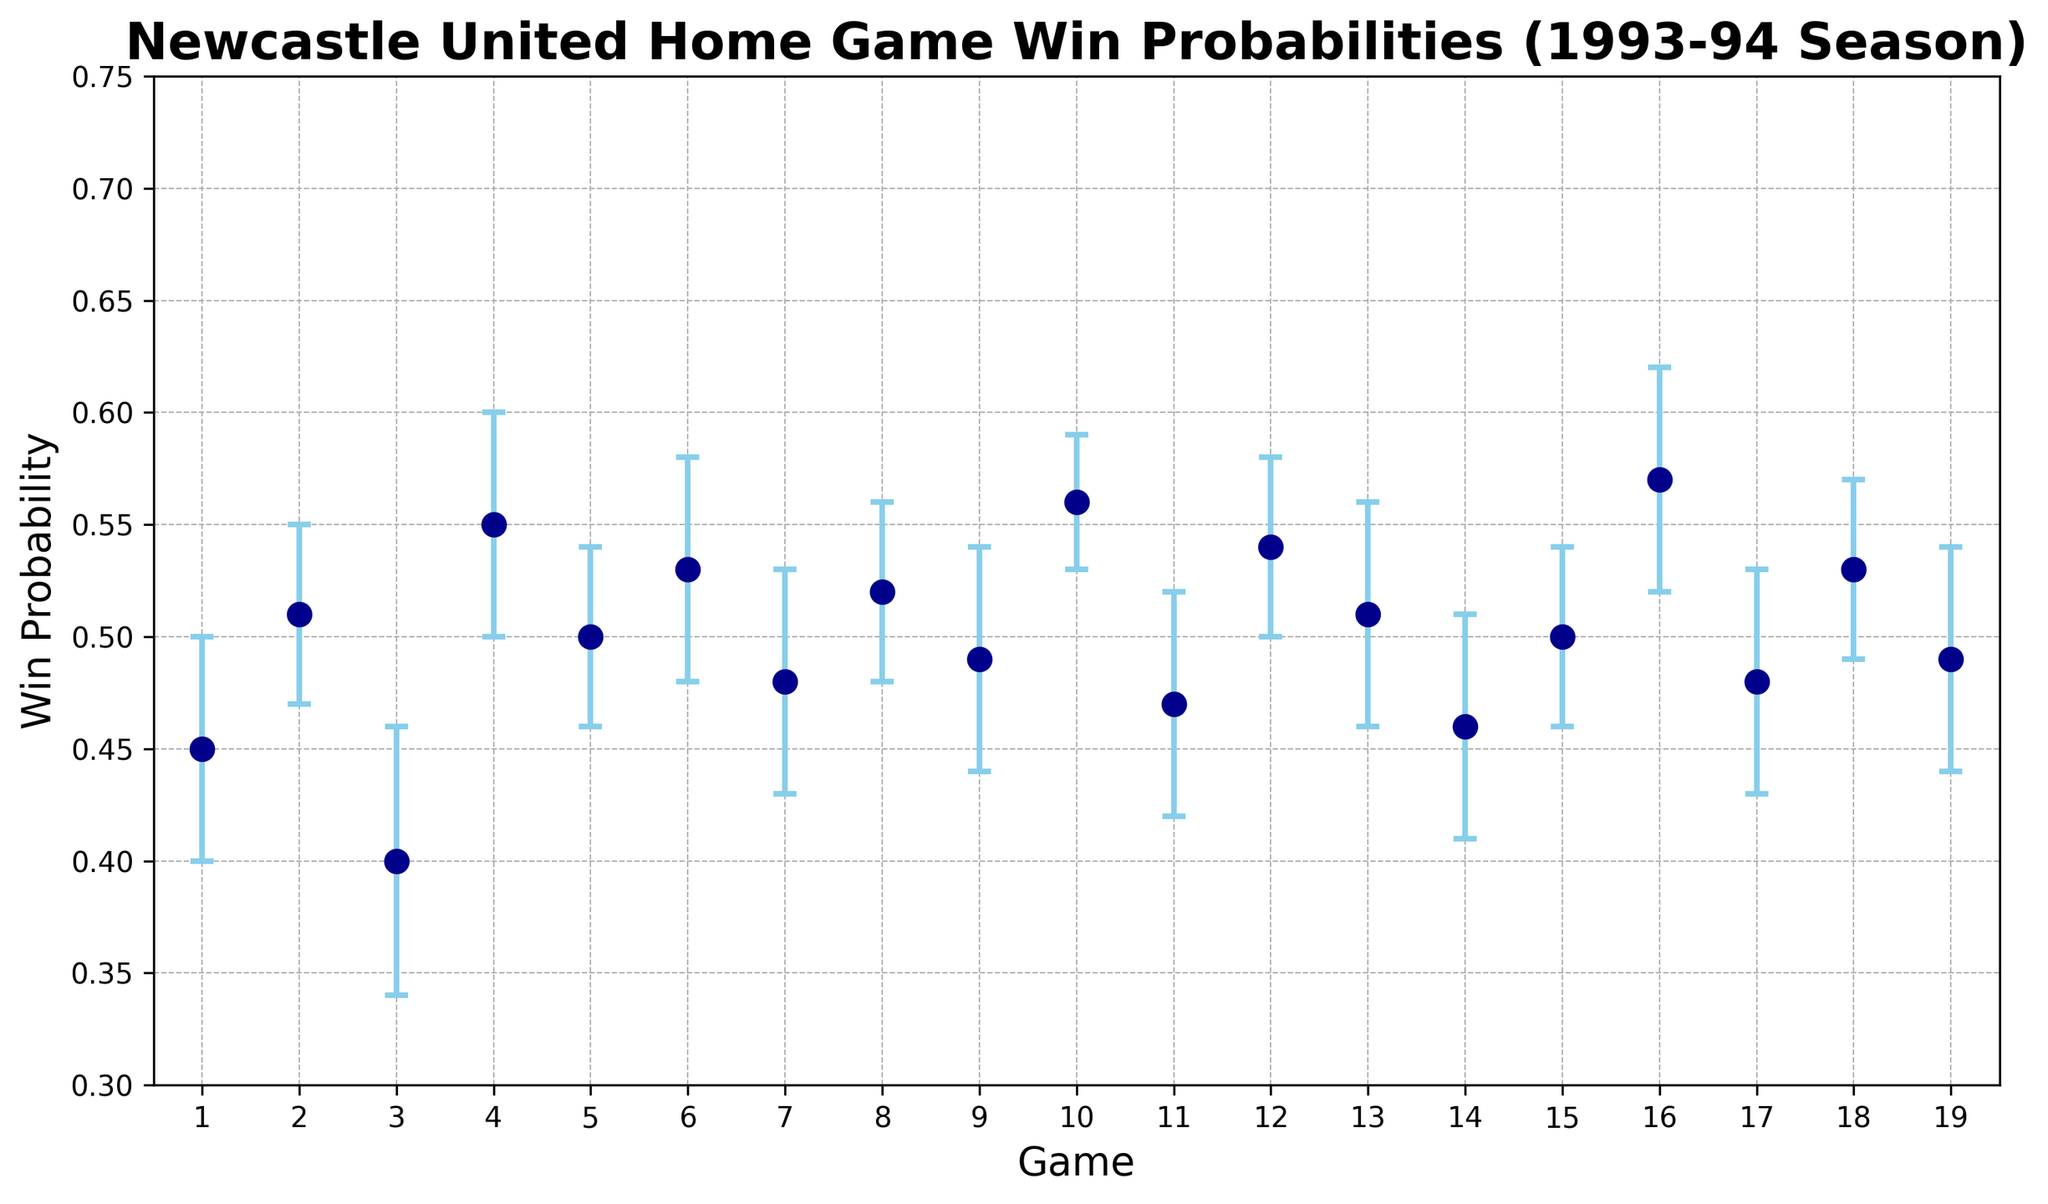what is the win probability for Game 10? Look at the point corresponding to Game 10 along the x-axis, and check the win probability value on the y-axis. The win probability for Game 10 is marked as 0.56.
Answer: 0.56 which game has the highest win probability? Check which point on the plot has the highest y-axis value. Game 16 shows the highest win probability of 0.57.
Answer: Game 16 which game has the lowest win probability? Check which point on the plot has the lowest y-axis value. Game 3 shows the lowest win probability of 0.40.
Answer: Game 3 what’s the average win probability of the first and last game combined? Add the win probabilities of Game 1 (0.45) and Game 19 (0.49), then divide by 2. (0.45 + 0.49) / 2 = 0.47.
Answer: 0.47 compare the win probabilities between Game 4 and Game 12, which one is higher? Check the win probabilities on the y-axis for Game 4 (0.55) and Game 12 (0.54), Game 4's probability is higher.
Answer: Game 4 is the win probability of Game 7 within the error margin of Game 8? The win probability of Game 7 is 0.48 with an error estimate of 0.05, and Game 8 is 0.52 with an error estimate of 0.04. The range for Game 7 is 0.48 ± 0.05, which spans from 0.43 to 0.53. The win probability for Game 8 is within this range.
Answer: Yes what is the range of the win probability for Game 6? The win probability of Game 6 is 0.53 with an error estimate of 0.05, so the range is 0.53 ± 0.05, which spans from 0.48 to 0.58.
Answer: 0.48 to 0.58 how many games have win probabilities greater than 0.50? Count the number of points above the 0.50 mark on the y-axis. There are 10 games with probabilities higher than 0.50 (Game 2, 4, 5, 6, 8, 10, 12, 13, 16, and 18).
Answer: 10 which games have a win probability equal to 0.50? Check the points on the plot where the y-axis value is exactly 0.50. Game 5 and Game 15 have a win probability of 0.50.
Answer: Game 5, Game 15 